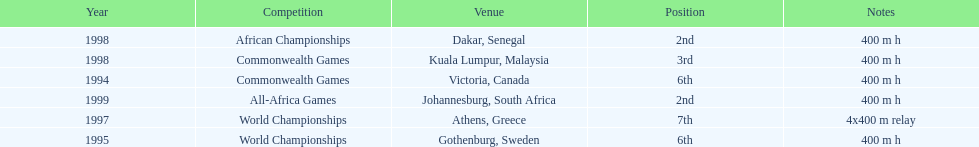Give me the full table as a dictionary. {'header': ['Year', 'Competition', 'Venue', 'Position', 'Notes'], 'rows': [['1998', 'African Championships', 'Dakar, Senegal', '2nd', '400 m h'], ['1998', 'Commonwealth Games', 'Kuala Lumpur, Malaysia', '3rd', '400 m h'], ['1994', 'Commonwealth Games', 'Victoria, Canada', '6th', '400 m h'], ['1999', 'All-Africa Games', 'Johannesburg, South Africa', '2nd', '400 m h'], ['1997', 'World Championships', 'Athens, Greece', '7th', '4x400 m relay'], ['1995', 'World Championships', 'Gothenburg, Sweden', '6th', '400 m h']]} Other than 1999, what year did ken harnden win second place? 1998. 